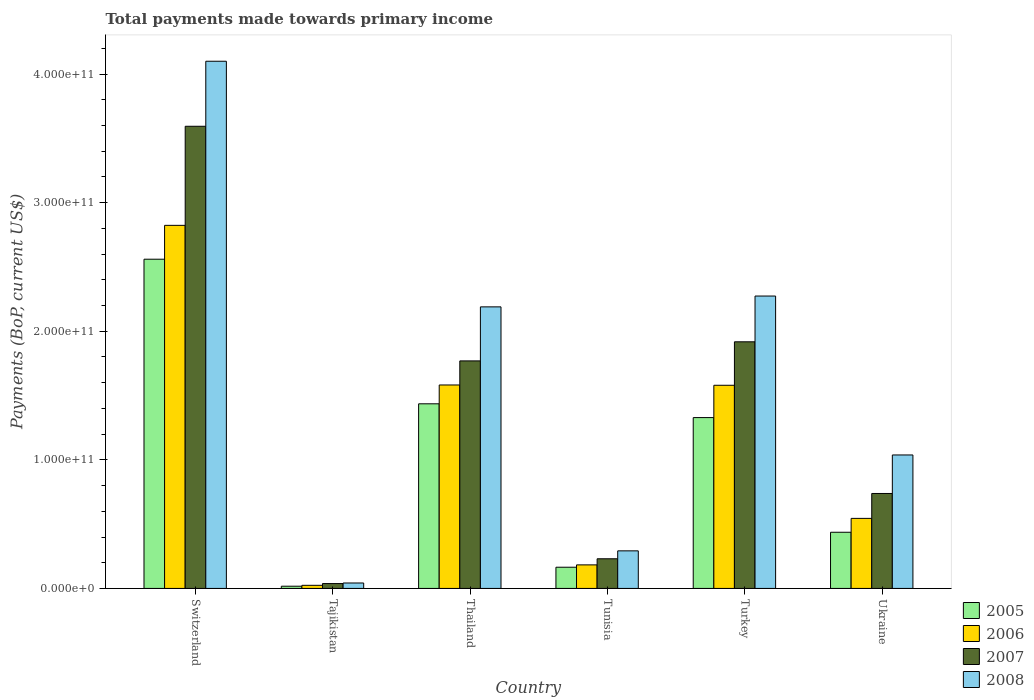How many different coloured bars are there?
Your response must be concise. 4. How many groups of bars are there?
Keep it short and to the point. 6. Are the number of bars on each tick of the X-axis equal?
Keep it short and to the point. Yes. How many bars are there on the 3rd tick from the left?
Give a very brief answer. 4. How many bars are there on the 6th tick from the right?
Offer a very short reply. 4. What is the label of the 4th group of bars from the left?
Your response must be concise. Tunisia. In how many cases, is the number of bars for a given country not equal to the number of legend labels?
Ensure brevity in your answer.  0. What is the total payments made towards primary income in 2005 in Ukraine?
Your answer should be very brief. 4.37e+1. Across all countries, what is the maximum total payments made towards primary income in 2008?
Make the answer very short. 4.10e+11. Across all countries, what is the minimum total payments made towards primary income in 2007?
Keep it short and to the point. 3.78e+09. In which country was the total payments made towards primary income in 2005 maximum?
Ensure brevity in your answer.  Switzerland. In which country was the total payments made towards primary income in 2008 minimum?
Provide a short and direct response. Tajikistan. What is the total total payments made towards primary income in 2005 in the graph?
Ensure brevity in your answer.  5.94e+11. What is the difference between the total payments made towards primary income in 2007 in Tajikistan and that in Turkey?
Your answer should be very brief. -1.88e+11. What is the difference between the total payments made towards primary income in 2006 in Thailand and the total payments made towards primary income in 2007 in Ukraine?
Provide a short and direct response. 8.44e+1. What is the average total payments made towards primary income in 2006 per country?
Your answer should be compact. 1.12e+11. What is the difference between the total payments made towards primary income of/in 2008 and total payments made towards primary income of/in 2005 in Turkey?
Your response must be concise. 9.45e+1. What is the ratio of the total payments made towards primary income in 2006 in Thailand to that in Tunisia?
Provide a succinct answer. 8.64. Is the difference between the total payments made towards primary income in 2008 in Thailand and Ukraine greater than the difference between the total payments made towards primary income in 2005 in Thailand and Ukraine?
Offer a terse response. Yes. What is the difference between the highest and the second highest total payments made towards primary income in 2007?
Offer a terse response. 1.82e+11. What is the difference between the highest and the lowest total payments made towards primary income in 2008?
Give a very brief answer. 4.06e+11. Is the sum of the total payments made towards primary income in 2008 in Tajikistan and Turkey greater than the maximum total payments made towards primary income in 2006 across all countries?
Give a very brief answer. No. Is it the case that in every country, the sum of the total payments made towards primary income in 2005 and total payments made towards primary income in 2007 is greater than the sum of total payments made towards primary income in 2008 and total payments made towards primary income in 2006?
Keep it short and to the point. No. Is it the case that in every country, the sum of the total payments made towards primary income in 2006 and total payments made towards primary income in 2005 is greater than the total payments made towards primary income in 2007?
Your response must be concise. Yes. How many bars are there?
Make the answer very short. 24. How many countries are there in the graph?
Your response must be concise. 6. What is the difference between two consecutive major ticks on the Y-axis?
Keep it short and to the point. 1.00e+11. Are the values on the major ticks of Y-axis written in scientific E-notation?
Give a very brief answer. Yes. What is the title of the graph?
Your answer should be very brief. Total payments made towards primary income. Does "1979" appear as one of the legend labels in the graph?
Offer a terse response. No. What is the label or title of the Y-axis?
Make the answer very short. Payments (BoP, current US$). What is the Payments (BoP, current US$) of 2005 in Switzerland?
Give a very brief answer. 2.56e+11. What is the Payments (BoP, current US$) of 2006 in Switzerland?
Keep it short and to the point. 2.82e+11. What is the Payments (BoP, current US$) in 2007 in Switzerland?
Provide a succinct answer. 3.59e+11. What is the Payments (BoP, current US$) of 2008 in Switzerland?
Give a very brief answer. 4.10e+11. What is the Payments (BoP, current US$) in 2005 in Tajikistan?
Make the answer very short. 1.73e+09. What is the Payments (BoP, current US$) in 2006 in Tajikistan?
Make the answer very short. 2.43e+09. What is the Payments (BoP, current US$) in 2007 in Tajikistan?
Offer a terse response. 3.78e+09. What is the Payments (BoP, current US$) of 2008 in Tajikistan?
Your response must be concise. 4.23e+09. What is the Payments (BoP, current US$) in 2005 in Thailand?
Provide a succinct answer. 1.44e+11. What is the Payments (BoP, current US$) in 2006 in Thailand?
Offer a very short reply. 1.58e+11. What is the Payments (BoP, current US$) of 2007 in Thailand?
Provide a succinct answer. 1.77e+11. What is the Payments (BoP, current US$) of 2008 in Thailand?
Provide a succinct answer. 2.19e+11. What is the Payments (BoP, current US$) in 2005 in Tunisia?
Provide a short and direct response. 1.65e+1. What is the Payments (BoP, current US$) of 2006 in Tunisia?
Your answer should be very brief. 1.83e+1. What is the Payments (BoP, current US$) in 2007 in Tunisia?
Provide a short and direct response. 2.31e+1. What is the Payments (BoP, current US$) of 2008 in Tunisia?
Provide a succinct answer. 2.92e+1. What is the Payments (BoP, current US$) in 2005 in Turkey?
Provide a short and direct response. 1.33e+11. What is the Payments (BoP, current US$) of 2006 in Turkey?
Ensure brevity in your answer.  1.58e+11. What is the Payments (BoP, current US$) in 2007 in Turkey?
Provide a short and direct response. 1.92e+11. What is the Payments (BoP, current US$) in 2008 in Turkey?
Offer a terse response. 2.27e+11. What is the Payments (BoP, current US$) in 2005 in Ukraine?
Offer a terse response. 4.37e+1. What is the Payments (BoP, current US$) in 2006 in Ukraine?
Your answer should be compact. 5.45e+1. What is the Payments (BoP, current US$) of 2007 in Ukraine?
Keep it short and to the point. 7.39e+1. What is the Payments (BoP, current US$) of 2008 in Ukraine?
Keep it short and to the point. 1.04e+11. Across all countries, what is the maximum Payments (BoP, current US$) of 2005?
Provide a succinct answer. 2.56e+11. Across all countries, what is the maximum Payments (BoP, current US$) in 2006?
Ensure brevity in your answer.  2.82e+11. Across all countries, what is the maximum Payments (BoP, current US$) in 2007?
Provide a succinct answer. 3.59e+11. Across all countries, what is the maximum Payments (BoP, current US$) in 2008?
Provide a succinct answer. 4.10e+11. Across all countries, what is the minimum Payments (BoP, current US$) in 2005?
Your answer should be very brief. 1.73e+09. Across all countries, what is the minimum Payments (BoP, current US$) of 2006?
Provide a short and direct response. 2.43e+09. Across all countries, what is the minimum Payments (BoP, current US$) of 2007?
Keep it short and to the point. 3.78e+09. Across all countries, what is the minimum Payments (BoP, current US$) in 2008?
Offer a very short reply. 4.23e+09. What is the total Payments (BoP, current US$) in 2005 in the graph?
Your response must be concise. 5.94e+11. What is the total Payments (BoP, current US$) in 2006 in the graph?
Give a very brief answer. 6.74e+11. What is the total Payments (BoP, current US$) in 2007 in the graph?
Keep it short and to the point. 8.29e+11. What is the total Payments (BoP, current US$) of 2008 in the graph?
Keep it short and to the point. 9.94e+11. What is the difference between the Payments (BoP, current US$) of 2005 in Switzerland and that in Tajikistan?
Make the answer very short. 2.54e+11. What is the difference between the Payments (BoP, current US$) of 2006 in Switzerland and that in Tajikistan?
Your answer should be compact. 2.80e+11. What is the difference between the Payments (BoP, current US$) in 2007 in Switzerland and that in Tajikistan?
Make the answer very short. 3.56e+11. What is the difference between the Payments (BoP, current US$) of 2008 in Switzerland and that in Tajikistan?
Your answer should be compact. 4.06e+11. What is the difference between the Payments (BoP, current US$) in 2005 in Switzerland and that in Thailand?
Your response must be concise. 1.12e+11. What is the difference between the Payments (BoP, current US$) of 2006 in Switzerland and that in Thailand?
Your response must be concise. 1.24e+11. What is the difference between the Payments (BoP, current US$) in 2007 in Switzerland and that in Thailand?
Make the answer very short. 1.82e+11. What is the difference between the Payments (BoP, current US$) of 2008 in Switzerland and that in Thailand?
Your answer should be compact. 1.91e+11. What is the difference between the Payments (BoP, current US$) in 2005 in Switzerland and that in Tunisia?
Your answer should be very brief. 2.40e+11. What is the difference between the Payments (BoP, current US$) of 2006 in Switzerland and that in Tunisia?
Provide a succinct answer. 2.64e+11. What is the difference between the Payments (BoP, current US$) of 2007 in Switzerland and that in Tunisia?
Offer a terse response. 3.36e+11. What is the difference between the Payments (BoP, current US$) of 2008 in Switzerland and that in Tunisia?
Your answer should be very brief. 3.81e+11. What is the difference between the Payments (BoP, current US$) of 2005 in Switzerland and that in Turkey?
Ensure brevity in your answer.  1.23e+11. What is the difference between the Payments (BoP, current US$) of 2006 in Switzerland and that in Turkey?
Keep it short and to the point. 1.24e+11. What is the difference between the Payments (BoP, current US$) of 2007 in Switzerland and that in Turkey?
Your answer should be very brief. 1.68e+11. What is the difference between the Payments (BoP, current US$) in 2008 in Switzerland and that in Turkey?
Make the answer very short. 1.83e+11. What is the difference between the Payments (BoP, current US$) in 2005 in Switzerland and that in Ukraine?
Provide a short and direct response. 2.12e+11. What is the difference between the Payments (BoP, current US$) of 2006 in Switzerland and that in Ukraine?
Make the answer very short. 2.28e+11. What is the difference between the Payments (BoP, current US$) of 2007 in Switzerland and that in Ukraine?
Offer a terse response. 2.86e+11. What is the difference between the Payments (BoP, current US$) of 2008 in Switzerland and that in Ukraine?
Offer a very short reply. 3.06e+11. What is the difference between the Payments (BoP, current US$) of 2005 in Tajikistan and that in Thailand?
Ensure brevity in your answer.  -1.42e+11. What is the difference between the Payments (BoP, current US$) of 2006 in Tajikistan and that in Thailand?
Provide a succinct answer. -1.56e+11. What is the difference between the Payments (BoP, current US$) in 2007 in Tajikistan and that in Thailand?
Keep it short and to the point. -1.73e+11. What is the difference between the Payments (BoP, current US$) in 2008 in Tajikistan and that in Thailand?
Ensure brevity in your answer.  -2.15e+11. What is the difference between the Payments (BoP, current US$) in 2005 in Tajikistan and that in Tunisia?
Your answer should be compact. -1.48e+1. What is the difference between the Payments (BoP, current US$) in 2006 in Tajikistan and that in Tunisia?
Your answer should be compact. -1.59e+1. What is the difference between the Payments (BoP, current US$) of 2007 in Tajikistan and that in Tunisia?
Ensure brevity in your answer.  -1.93e+1. What is the difference between the Payments (BoP, current US$) in 2008 in Tajikistan and that in Tunisia?
Ensure brevity in your answer.  -2.50e+1. What is the difference between the Payments (BoP, current US$) of 2005 in Tajikistan and that in Turkey?
Make the answer very short. -1.31e+11. What is the difference between the Payments (BoP, current US$) in 2006 in Tajikistan and that in Turkey?
Your response must be concise. -1.56e+11. What is the difference between the Payments (BoP, current US$) of 2007 in Tajikistan and that in Turkey?
Offer a very short reply. -1.88e+11. What is the difference between the Payments (BoP, current US$) of 2008 in Tajikistan and that in Turkey?
Make the answer very short. -2.23e+11. What is the difference between the Payments (BoP, current US$) of 2005 in Tajikistan and that in Ukraine?
Ensure brevity in your answer.  -4.20e+1. What is the difference between the Payments (BoP, current US$) of 2006 in Tajikistan and that in Ukraine?
Ensure brevity in your answer.  -5.21e+1. What is the difference between the Payments (BoP, current US$) in 2007 in Tajikistan and that in Ukraine?
Provide a short and direct response. -7.01e+1. What is the difference between the Payments (BoP, current US$) of 2008 in Tajikistan and that in Ukraine?
Make the answer very short. -9.96e+1. What is the difference between the Payments (BoP, current US$) in 2005 in Thailand and that in Tunisia?
Your answer should be compact. 1.27e+11. What is the difference between the Payments (BoP, current US$) in 2006 in Thailand and that in Tunisia?
Provide a short and direct response. 1.40e+11. What is the difference between the Payments (BoP, current US$) in 2007 in Thailand and that in Tunisia?
Provide a succinct answer. 1.54e+11. What is the difference between the Payments (BoP, current US$) in 2008 in Thailand and that in Tunisia?
Make the answer very short. 1.90e+11. What is the difference between the Payments (BoP, current US$) of 2005 in Thailand and that in Turkey?
Your answer should be compact. 1.07e+1. What is the difference between the Payments (BoP, current US$) in 2006 in Thailand and that in Turkey?
Offer a very short reply. 2.24e+08. What is the difference between the Payments (BoP, current US$) in 2007 in Thailand and that in Turkey?
Your response must be concise. -1.48e+1. What is the difference between the Payments (BoP, current US$) of 2008 in Thailand and that in Turkey?
Ensure brevity in your answer.  -8.42e+09. What is the difference between the Payments (BoP, current US$) of 2005 in Thailand and that in Ukraine?
Provide a short and direct response. 9.99e+1. What is the difference between the Payments (BoP, current US$) of 2006 in Thailand and that in Ukraine?
Your response must be concise. 1.04e+11. What is the difference between the Payments (BoP, current US$) in 2007 in Thailand and that in Ukraine?
Make the answer very short. 1.03e+11. What is the difference between the Payments (BoP, current US$) in 2008 in Thailand and that in Ukraine?
Keep it short and to the point. 1.15e+11. What is the difference between the Payments (BoP, current US$) of 2005 in Tunisia and that in Turkey?
Keep it short and to the point. -1.16e+11. What is the difference between the Payments (BoP, current US$) in 2006 in Tunisia and that in Turkey?
Make the answer very short. -1.40e+11. What is the difference between the Payments (BoP, current US$) in 2007 in Tunisia and that in Turkey?
Provide a succinct answer. -1.69e+11. What is the difference between the Payments (BoP, current US$) in 2008 in Tunisia and that in Turkey?
Offer a very short reply. -1.98e+11. What is the difference between the Payments (BoP, current US$) of 2005 in Tunisia and that in Ukraine?
Your answer should be compact. -2.72e+1. What is the difference between the Payments (BoP, current US$) of 2006 in Tunisia and that in Ukraine?
Provide a succinct answer. -3.62e+1. What is the difference between the Payments (BoP, current US$) of 2007 in Tunisia and that in Ukraine?
Your answer should be compact. -5.08e+1. What is the difference between the Payments (BoP, current US$) in 2008 in Tunisia and that in Ukraine?
Give a very brief answer. -7.46e+1. What is the difference between the Payments (BoP, current US$) of 2005 in Turkey and that in Ukraine?
Ensure brevity in your answer.  8.92e+1. What is the difference between the Payments (BoP, current US$) in 2006 in Turkey and that in Ukraine?
Keep it short and to the point. 1.04e+11. What is the difference between the Payments (BoP, current US$) in 2007 in Turkey and that in Ukraine?
Provide a short and direct response. 1.18e+11. What is the difference between the Payments (BoP, current US$) in 2008 in Turkey and that in Ukraine?
Offer a very short reply. 1.24e+11. What is the difference between the Payments (BoP, current US$) of 2005 in Switzerland and the Payments (BoP, current US$) of 2006 in Tajikistan?
Provide a short and direct response. 2.54e+11. What is the difference between the Payments (BoP, current US$) of 2005 in Switzerland and the Payments (BoP, current US$) of 2007 in Tajikistan?
Your answer should be very brief. 2.52e+11. What is the difference between the Payments (BoP, current US$) in 2005 in Switzerland and the Payments (BoP, current US$) in 2008 in Tajikistan?
Offer a very short reply. 2.52e+11. What is the difference between the Payments (BoP, current US$) in 2006 in Switzerland and the Payments (BoP, current US$) in 2007 in Tajikistan?
Provide a succinct answer. 2.79e+11. What is the difference between the Payments (BoP, current US$) of 2006 in Switzerland and the Payments (BoP, current US$) of 2008 in Tajikistan?
Your answer should be compact. 2.78e+11. What is the difference between the Payments (BoP, current US$) of 2007 in Switzerland and the Payments (BoP, current US$) of 2008 in Tajikistan?
Your answer should be compact. 3.55e+11. What is the difference between the Payments (BoP, current US$) in 2005 in Switzerland and the Payments (BoP, current US$) in 2006 in Thailand?
Provide a succinct answer. 9.78e+1. What is the difference between the Payments (BoP, current US$) in 2005 in Switzerland and the Payments (BoP, current US$) in 2007 in Thailand?
Your response must be concise. 7.91e+1. What is the difference between the Payments (BoP, current US$) of 2005 in Switzerland and the Payments (BoP, current US$) of 2008 in Thailand?
Provide a short and direct response. 3.71e+1. What is the difference between the Payments (BoP, current US$) in 2006 in Switzerland and the Payments (BoP, current US$) in 2007 in Thailand?
Offer a very short reply. 1.05e+11. What is the difference between the Payments (BoP, current US$) of 2006 in Switzerland and the Payments (BoP, current US$) of 2008 in Thailand?
Your response must be concise. 6.34e+1. What is the difference between the Payments (BoP, current US$) of 2007 in Switzerland and the Payments (BoP, current US$) of 2008 in Thailand?
Offer a very short reply. 1.40e+11. What is the difference between the Payments (BoP, current US$) of 2005 in Switzerland and the Payments (BoP, current US$) of 2006 in Tunisia?
Make the answer very short. 2.38e+11. What is the difference between the Payments (BoP, current US$) of 2005 in Switzerland and the Payments (BoP, current US$) of 2007 in Tunisia?
Ensure brevity in your answer.  2.33e+11. What is the difference between the Payments (BoP, current US$) in 2005 in Switzerland and the Payments (BoP, current US$) in 2008 in Tunisia?
Keep it short and to the point. 2.27e+11. What is the difference between the Payments (BoP, current US$) in 2006 in Switzerland and the Payments (BoP, current US$) in 2007 in Tunisia?
Give a very brief answer. 2.59e+11. What is the difference between the Payments (BoP, current US$) in 2006 in Switzerland and the Payments (BoP, current US$) in 2008 in Tunisia?
Ensure brevity in your answer.  2.53e+11. What is the difference between the Payments (BoP, current US$) of 2007 in Switzerland and the Payments (BoP, current US$) of 2008 in Tunisia?
Offer a very short reply. 3.30e+11. What is the difference between the Payments (BoP, current US$) of 2005 in Switzerland and the Payments (BoP, current US$) of 2006 in Turkey?
Give a very brief answer. 9.80e+1. What is the difference between the Payments (BoP, current US$) of 2005 in Switzerland and the Payments (BoP, current US$) of 2007 in Turkey?
Keep it short and to the point. 6.42e+1. What is the difference between the Payments (BoP, current US$) of 2005 in Switzerland and the Payments (BoP, current US$) of 2008 in Turkey?
Give a very brief answer. 2.86e+1. What is the difference between the Payments (BoP, current US$) of 2006 in Switzerland and the Payments (BoP, current US$) of 2007 in Turkey?
Ensure brevity in your answer.  9.06e+1. What is the difference between the Payments (BoP, current US$) in 2006 in Switzerland and the Payments (BoP, current US$) in 2008 in Turkey?
Keep it short and to the point. 5.50e+1. What is the difference between the Payments (BoP, current US$) of 2007 in Switzerland and the Payments (BoP, current US$) of 2008 in Turkey?
Give a very brief answer. 1.32e+11. What is the difference between the Payments (BoP, current US$) in 2005 in Switzerland and the Payments (BoP, current US$) in 2006 in Ukraine?
Your answer should be compact. 2.02e+11. What is the difference between the Payments (BoP, current US$) in 2005 in Switzerland and the Payments (BoP, current US$) in 2007 in Ukraine?
Your answer should be compact. 1.82e+11. What is the difference between the Payments (BoP, current US$) in 2005 in Switzerland and the Payments (BoP, current US$) in 2008 in Ukraine?
Your answer should be very brief. 1.52e+11. What is the difference between the Payments (BoP, current US$) of 2006 in Switzerland and the Payments (BoP, current US$) of 2007 in Ukraine?
Make the answer very short. 2.09e+11. What is the difference between the Payments (BoP, current US$) of 2006 in Switzerland and the Payments (BoP, current US$) of 2008 in Ukraine?
Offer a terse response. 1.79e+11. What is the difference between the Payments (BoP, current US$) of 2007 in Switzerland and the Payments (BoP, current US$) of 2008 in Ukraine?
Your answer should be compact. 2.56e+11. What is the difference between the Payments (BoP, current US$) of 2005 in Tajikistan and the Payments (BoP, current US$) of 2006 in Thailand?
Your response must be concise. -1.57e+11. What is the difference between the Payments (BoP, current US$) in 2005 in Tajikistan and the Payments (BoP, current US$) in 2007 in Thailand?
Offer a very short reply. -1.75e+11. What is the difference between the Payments (BoP, current US$) of 2005 in Tajikistan and the Payments (BoP, current US$) of 2008 in Thailand?
Your response must be concise. -2.17e+11. What is the difference between the Payments (BoP, current US$) in 2006 in Tajikistan and the Payments (BoP, current US$) in 2007 in Thailand?
Provide a succinct answer. -1.75e+11. What is the difference between the Payments (BoP, current US$) of 2006 in Tajikistan and the Payments (BoP, current US$) of 2008 in Thailand?
Your answer should be compact. -2.17e+11. What is the difference between the Payments (BoP, current US$) in 2007 in Tajikistan and the Payments (BoP, current US$) in 2008 in Thailand?
Your answer should be very brief. -2.15e+11. What is the difference between the Payments (BoP, current US$) of 2005 in Tajikistan and the Payments (BoP, current US$) of 2006 in Tunisia?
Keep it short and to the point. -1.66e+1. What is the difference between the Payments (BoP, current US$) in 2005 in Tajikistan and the Payments (BoP, current US$) in 2007 in Tunisia?
Your response must be concise. -2.13e+1. What is the difference between the Payments (BoP, current US$) of 2005 in Tajikistan and the Payments (BoP, current US$) of 2008 in Tunisia?
Offer a terse response. -2.75e+1. What is the difference between the Payments (BoP, current US$) of 2006 in Tajikistan and the Payments (BoP, current US$) of 2007 in Tunisia?
Offer a very short reply. -2.06e+1. What is the difference between the Payments (BoP, current US$) in 2006 in Tajikistan and the Payments (BoP, current US$) in 2008 in Tunisia?
Your response must be concise. -2.68e+1. What is the difference between the Payments (BoP, current US$) of 2007 in Tajikistan and the Payments (BoP, current US$) of 2008 in Tunisia?
Ensure brevity in your answer.  -2.55e+1. What is the difference between the Payments (BoP, current US$) in 2005 in Tajikistan and the Payments (BoP, current US$) in 2006 in Turkey?
Give a very brief answer. -1.56e+11. What is the difference between the Payments (BoP, current US$) of 2005 in Tajikistan and the Payments (BoP, current US$) of 2007 in Turkey?
Your response must be concise. -1.90e+11. What is the difference between the Payments (BoP, current US$) of 2005 in Tajikistan and the Payments (BoP, current US$) of 2008 in Turkey?
Make the answer very short. -2.26e+11. What is the difference between the Payments (BoP, current US$) of 2006 in Tajikistan and the Payments (BoP, current US$) of 2007 in Turkey?
Your answer should be compact. -1.89e+11. What is the difference between the Payments (BoP, current US$) in 2006 in Tajikistan and the Payments (BoP, current US$) in 2008 in Turkey?
Your answer should be compact. -2.25e+11. What is the difference between the Payments (BoP, current US$) in 2007 in Tajikistan and the Payments (BoP, current US$) in 2008 in Turkey?
Provide a succinct answer. -2.24e+11. What is the difference between the Payments (BoP, current US$) of 2005 in Tajikistan and the Payments (BoP, current US$) of 2006 in Ukraine?
Provide a short and direct response. -5.27e+1. What is the difference between the Payments (BoP, current US$) of 2005 in Tajikistan and the Payments (BoP, current US$) of 2007 in Ukraine?
Keep it short and to the point. -7.21e+1. What is the difference between the Payments (BoP, current US$) in 2005 in Tajikistan and the Payments (BoP, current US$) in 2008 in Ukraine?
Give a very brief answer. -1.02e+11. What is the difference between the Payments (BoP, current US$) in 2006 in Tajikistan and the Payments (BoP, current US$) in 2007 in Ukraine?
Your answer should be compact. -7.14e+1. What is the difference between the Payments (BoP, current US$) in 2006 in Tajikistan and the Payments (BoP, current US$) in 2008 in Ukraine?
Provide a short and direct response. -1.01e+11. What is the difference between the Payments (BoP, current US$) in 2007 in Tajikistan and the Payments (BoP, current US$) in 2008 in Ukraine?
Keep it short and to the point. -1.00e+11. What is the difference between the Payments (BoP, current US$) of 2005 in Thailand and the Payments (BoP, current US$) of 2006 in Tunisia?
Provide a succinct answer. 1.25e+11. What is the difference between the Payments (BoP, current US$) of 2005 in Thailand and the Payments (BoP, current US$) of 2007 in Tunisia?
Provide a succinct answer. 1.21e+11. What is the difference between the Payments (BoP, current US$) of 2005 in Thailand and the Payments (BoP, current US$) of 2008 in Tunisia?
Offer a very short reply. 1.14e+11. What is the difference between the Payments (BoP, current US$) in 2006 in Thailand and the Payments (BoP, current US$) in 2007 in Tunisia?
Offer a terse response. 1.35e+11. What is the difference between the Payments (BoP, current US$) of 2006 in Thailand and the Payments (BoP, current US$) of 2008 in Tunisia?
Provide a short and direct response. 1.29e+11. What is the difference between the Payments (BoP, current US$) in 2007 in Thailand and the Payments (BoP, current US$) in 2008 in Tunisia?
Keep it short and to the point. 1.48e+11. What is the difference between the Payments (BoP, current US$) of 2005 in Thailand and the Payments (BoP, current US$) of 2006 in Turkey?
Your answer should be compact. -1.44e+1. What is the difference between the Payments (BoP, current US$) of 2005 in Thailand and the Payments (BoP, current US$) of 2007 in Turkey?
Offer a very short reply. -4.82e+1. What is the difference between the Payments (BoP, current US$) of 2005 in Thailand and the Payments (BoP, current US$) of 2008 in Turkey?
Your answer should be very brief. -8.38e+1. What is the difference between the Payments (BoP, current US$) in 2006 in Thailand and the Payments (BoP, current US$) in 2007 in Turkey?
Offer a terse response. -3.36e+1. What is the difference between the Payments (BoP, current US$) in 2006 in Thailand and the Payments (BoP, current US$) in 2008 in Turkey?
Your response must be concise. -6.92e+1. What is the difference between the Payments (BoP, current US$) of 2007 in Thailand and the Payments (BoP, current US$) of 2008 in Turkey?
Your answer should be very brief. -5.04e+1. What is the difference between the Payments (BoP, current US$) in 2005 in Thailand and the Payments (BoP, current US$) in 2006 in Ukraine?
Offer a terse response. 8.91e+1. What is the difference between the Payments (BoP, current US$) in 2005 in Thailand and the Payments (BoP, current US$) in 2007 in Ukraine?
Give a very brief answer. 6.97e+1. What is the difference between the Payments (BoP, current US$) of 2005 in Thailand and the Payments (BoP, current US$) of 2008 in Ukraine?
Your answer should be compact. 3.98e+1. What is the difference between the Payments (BoP, current US$) of 2006 in Thailand and the Payments (BoP, current US$) of 2007 in Ukraine?
Ensure brevity in your answer.  8.44e+1. What is the difference between the Payments (BoP, current US$) in 2006 in Thailand and the Payments (BoP, current US$) in 2008 in Ukraine?
Provide a succinct answer. 5.44e+1. What is the difference between the Payments (BoP, current US$) in 2007 in Thailand and the Payments (BoP, current US$) in 2008 in Ukraine?
Your response must be concise. 7.32e+1. What is the difference between the Payments (BoP, current US$) in 2005 in Tunisia and the Payments (BoP, current US$) in 2006 in Turkey?
Make the answer very short. -1.42e+11. What is the difference between the Payments (BoP, current US$) of 2005 in Tunisia and the Payments (BoP, current US$) of 2007 in Turkey?
Keep it short and to the point. -1.75e+11. What is the difference between the Payments (BoP, current US$) in 2005 in Tunisia and the Payments (BoP, current US$) in 2008 in Turkey?
Give a very brief answer. -2.11e+11. What is the difference between the Payments (BoP, current US$) of 2006 in Tunisia and the Payments (BoP, current US$) of 2007 in Turkey?
Offer a very short reply. -1.73e+11. What is the difference between the Payments (BoP, current US$) of 2006 in Tunisia and the Payments (BoP, current US$) of 2008 in Turkey?
Provide a short and direct response. -2.09e+11. What is the difference between the Payments (BoP, current US$) in 2007 in Tunisia and the Payments (BoP, current US$) in 2008 in Turkey?
Make the answer very short. -2.04e+11. What is the difference between the Payments (BoP, current US$) of 2005 in Tunisia and the Payments (BoP, current US$) of 2006 in Ukraine?
Give a very brief answer. -3.80e+1. What is the difference between the Payments (BoP, current US$) of 2005 in Tunisia and the Payments (BoP, current US$) of 2007 in Ukraine?
Give a very brief answer. -5.74e+1. What is the difference between the Payments (BoP, current US$) in 2005 in Tunisia and the Payments (BoP, current US$) in 2008 in Ukraine?
Provide a short and direct response. -8.73e+1. What is the difference between the Payments (BoP, current US$) of 2006 in Tunisia and the Payments (BoP, current US$) of 2007 in Ukraine?
Your answer should be compact. -5.55e+1. What is the difference between the Payments (BoP, current US$) of 2006 in Tunisia and the Payments (BoP, current US$) of 2008 in Ukraine?
Keep it short and to the point. -8.55e+1. What is the difference between the Payments (BoP, current US$) in 2007 in Tunisia and the Payments (BoP, current US$) in 2008 in Ukraine?
Offer a terse response. -8.07e+1. What is the difference between the Payments (BoP, current US$) of 2005 in Turkey and the Payments (BoP, current US$) of 2006 in Ukraine?
Provide a short and direct response. 7.84e+1. What is the difference between the Payments (BoP, current US$) in 2005 in Turkey and the Payments (BoP, current US$) in 2007 in Ukraine?
Ensure brevity in your answer.  5.90e+1. What is the difference between the Payments (BoP, current US$) in 2005 in Turkey and the Payments (BoP, current US$) in 2008 in Ukraine?
Your response must be concise. 2.91e+1. What is the difference between the Payments (BoP, current US$) of 2006 in Turkey and the Payments (BoP, current US$) of 2007 in Ukraine?
Your answer should be compact. 8.42e+1. What is the difference between the Payments (BoP, current US$) of 2006 in Turkey and the Payments (BoP, current US$) of 2008 in Ukraine?
Ensure brevity in your answer.  5.42e+1. What is the difference between the Payments (BoP, current US$) of 2007 in Turkey and the Payments (BoP, current US$) of 2008 in Ukraine?
Offer a terse response. 8.80e+1. What is the average Payments (BoP, current US$) of 2005 per country?
Ensure brevity in your answer.  9.91e+1. What is the average Payments (BoP, current US$) of 2006 per country?
Your answer should be compact. 1.12e+11. What is the average Payments (BoP, current US$) in 2007 per country?
Ensure brevity in your answer.  1.38e+11. What is the average Payments (BoP, current US$) in 2008 per country?
Keep it short and to the point. 1.66e+11. What is the difference between the Payments (BoP, current US$) in 2005 and Payments (BoP, current US$) in 2006 in Switzerland?
Ensure brevity in your answer.  -2.63e+1. What is the difference between the Payments (BoP, current US$) of 2005 and Payments (BoP, current US$) of 2007 in Switzerland?
Offer a terse response. -1.03e+11. What is the difference between the Payments (BoP, current US$) of 2005 and Payments (BoP, current US$) of 2008 in Switzerland?
Ensure brevity in your answer.  -1.54e+11. What is the difference between the Payments (BoP, current US$) in 2006 and Payments (BoP, current US$) in 2007 in Switzerland?
Offer a very short reply. -7.71e+1. What is the difference between the Payments (BoP, current US$) of 2006 and Payments (BoP, current US$) of 2008 in Switzerland?
Offer a terse response. -1.28e+11. What is the difference between the Payments (BoP, current US$) of 2007 and Payments (BoP, current US$) of 2008 in Switzerland?
Ensure brevity in your answer.  -5.06e+1. What is the difference between the Payments (BoP, current US$) in 2005 and Payments (BoP, current US$) in 2006 in Tajikistan?
Your response must be concise. -6.93e+08. What is the difference between the Payments (BoP, current US$) of 2005 and Payments (BoP, current US$) of 2007 in Tajikistan?
Your answer should be very brief. -2.05e+09. What is the difference between the Payments (BoP, current US$) in 2005 and Payments (BoP, current US$) in 2008 in Tajikistan?
Provide a short and direct response. -2.49e+09. What is the difference between the Payments (BoP, current US$) in 2006 and Payments (BoP, current US$) in 2007 in Tajikistan?
Give a very brief answer. -1.35e+09. What is the difference between the Payments (BoP, current US$) in 2006 and Payments (BoP, current US$) in 2008 in Tajikistan?
Provide a succinct answer. -1.80e+09. What is the difference between the Payments (BoP, current US$) of 2007 and Payments (BoP, current US$) of 2008 in Tajikistan?
Your answer should be compact. -4.47e+08. What is the difference between the Payments (BoP, current US$) in 2005 and Payments (BoP, current US$) in 2006 in Thailand?
Your answer should be compact. -1.46e+1. What is the difference between the Payments (BoP, current US$) in 2005 and Payments (BoP, current US$) in 2007 in Thailand?
Keep it short and to the point. -3.34e+1. What is the difference between the Payments (BoP, current US$) in 2005 and Payments (BoP, current US$) in 2008 in Thailand?
Make the answer very short. -7.54e+1. What is the difference between the Payments (BoP, current US$) in 2006 and Payments (BoP, current US$) in 2007 in Thailand?
Your answer should be compact. -1.87e+1. What is the difference between the Payments (BoP, current US$) of 2006 and Payments (BoP, current US$) of 2008 in Thailand?
Keep it short and to the point. -6.08e+1. What is the difference between the Payments (BoP, current US$) of 2007 and Payments (BoP, current US$) of 2008 in Thailand?
Make the answer very short. -4.20e+1. What is the difference between the Payments (BoP, current US$) in 2005 and Payments (BoP, current US$) in 2006 in Tunisia?
Your answer should be compact. -1.82e+09. What is the difference between the Payments (BoP, current US$) in 2005 and Payments (BoP, current US$) in 2007 in Tunisia?
Your answer should be very brief. -6.57e+09. What is the difference between the Payments (BoP, current US$) of 2005 and Payments (BoP, current US$) of 2008 in Tunisia?
Ensure brevity in your answer.  -1.27e+1. What is the difference between the Payments (BoP, current US$) of 2006 and Payments (BoP, current US$) of 2007 in Tunisia?
Ensure brevity in your answer.  -4.74e+09. What is the difference between the Payments (BoP, current US$) in 2006 and Payments (BoP, current US$) in 2008 in Tunisia?
Offer a terse response. -1.09e+1. What is the difference between the Payments (BoP, current US$) of 2007 and Payments (BoP, current US$) of 2008 in Tunisia?
Offer a terse response. -6.17e+09. What is the difference between the Payments (BoP, current US$) of 2005 and Payments (BoP, current US$) of 2006 in Turkey?
Your response must be concise. -2.51e+1. What is the difference between the Payments (BoP, current US$) in 2005 and Payments (BoP, current US$) in 2007 in Turkey?
Your response must be concise. -5.89e+1. What is the difference between the Payments (BoP, current US$) in 2005 and Payments (BoP, current US$) in 2008 in Turkey?
Your answer should be very brief. -9.45e+1. What is the difference between the Payments (BoP, current US$) in 2006 and Payments (BoP, current US$) in 2007 in Turkey?
Ensure brevity in your answer.  -3.38e+1. What is the difference between the Payments (BoP, current US$) of 2006 and Payments (BoP, current US$) of 2008 in Turkey?
Make the answer very short. -6.94e+1. What is the difference between the Payments (BoP, current US$) in 2007 and Payments (BoP, current US$) in 2008 in Turkey?
Provide a succinct answer. -3.56e+1. What is the difference between the Payments (BoP, current US$) of 2005 and Payments (BoP, current US$) of 2006 in Ukraine?
Your response must be concise. -1.08e+1. What is the difference between the Payments (BoP, current US$) in 2005 and Payments (BoP, current US$) in 2007 in Ukraine?
Your answer should be compact. -3.02e+1. What is the difference between the Payments (BoP, current US$) of 2005 and Payments (BoP, current US$) of 2008 in Ukraine?
Offer a terse response. -6.01e+1. What is the difference between the Payments (BoP, current US$) of 2006 and Payments (BoP, current US$) of 2007 in Ukraine?
Ensure brevity in your answer.  -1.94e+1. What is the difference between the Payments (BoP, current US$) in 2006 and Payments (BoP, current US$) in 2008 in Ukraine?
Keep it short and to the point. -4.93e+1. What is the difference between the Payments (BoP, current US$) in 2007 and Payments (BoP, current US$) in 2008 in Ukraine?
Your answer should be very brief. -2.99e+1. What is the ratio of the Payments (BoP, current US$) of 2005 in Switzerland to that in Tajikistan?
Keep it short and to the point. 147.77. What is the ratio of the Payments (BoP, current US$) in 2006 in Switzerland to that in Tajikistan?
Make the answer very short. 116.43. What is the ratio of the Payments (BoP, current US$) of 2007 in Switzerland to that in Tajikistan?
Your response must be concise. 95.09. What is the ratio of the Payments (BoP, current US$) in 2008 in Switzerland to that in Tajikistan?
Your response must be concise. 97. What is the ratio of the Payments (BoP, current US$) in 2005 in Switzerland to that in Thailand?
Provide a short and direct response. 1.78. What is the ratio of the Payments (BoP, current US$) of 2006 in Switzerland to that in Thailand?
Your answer should be compact. 1.78. What is the ratio of the Payments (BoP, current US$) of 2007 in Switzerland to that in Thailand?
Make the answer very short. 2.03. What is the ratio of the Payments (BoP, current US$) of 2008 in Switzerland to that in Thailand?
Provide a succinct answer. 1.87. What is the ratio of the Payments (BoP, current US$) in 2005 in Switzerland to that in Tunisia?
Give a very brief answer. 15.52. What is the ratio of the Payments (BoP, current US$) of 2006 in Switzerland to that in Tunisia?
Provide a short and direct response. 15.41. What is the ratio of the Payments (BoP, current US$) in 2007 in Switzerland to that in Tunisia?
Make the answer very short. 15.59. What is the ratio of the Payments (BoP, current US$) in 2008 in Switzerland to that in Tunisia?
Your answer should be compact. 14.03. What is the ratio of the Payments (BoP, current US$) in 2005 in Switzerland to that in Turkey?
Provide a short and direct response. 1.93. What is the ratio of the Payments (BoP, current US$) in 2006 in Switzerland to that in Turkey?
Ensure brevity in your answer.  1.79. What is the ratio of the Payments (BoP, current US$) of 2007 in Switzerland to that in Turkey?
Provide a short and direct response. 1.87. What is the ratio of the Payments (BoP, current US$) in 2008 in Switzerland to that in Turkey?
Ensure brevity in your answer.  1.8. What is the ratio of the Payments (BoP, current US$) in 2005 in Switzerland to that in Ukraine?
Your answer should be very brief. 5.86. What is the ratio of the Payments (BoP, current US$) in 2006 in Switzerland to that in Ukraine?
Your response must be concise. 5.18. What is the ratio of the Payments (BoP, current US$) in 2007 in Switzerland to that in Ukraine?
Your response must be concise. 4.87. What is the ratio of the Payments (BoP, current US$) of 2008 in Switzerland to that in Ukraine?
Your response must be concise. 3.95. What is the ratio of the Payments (BoP, current US$) in 2005 in Tajikistan to that in Thailand?
Provide a short and direct response. 0.01. What is the ratio of the Payments (BoP, current US$) in 2006 in Tajikistan to that in Thailand?
Give a very brief answer. 0.02. What is the ratio of the Payments (BoP, current US$) in 2007 in Tajikistan to that in Thailand?
Offer a very short reply. 0.02. What is the ratio of the Payments (BoP, current US$) of 2008 in Tajikistan to that in Thailand?
Ensure brevity in your answer.  0.02. What is the ratio of the Payments (BoP, current US$) in 2005 in Tajikistan to that in Tunisia?
Ensure brevity in your answer.  0.1. What is the ratio of the Payments (BoP, current US$) in 2006 in Tajikistan to that in Tunisia?
Offer a very short reply. 0.13. What is the ratio of the Payments (BoP, current US$) of 2007 in Tajikistan to that in Tunisia?
Offer a terse response. 0.16. What is the ratio of the Payments (BoP, current US$) of 2008 in Tajikistan to that in Tunisia?
Provide a succinct answer. 0.14. What is the ratio of the Payments (BoP, current US$) of 2005 in Tajikistan to that in Turkey?
Your answer should be very brief. 0.01. What is the ratio of the Payments (BoP, current US$) of 2006 in Tajikistan to that in Turkey?
Your answer should be compact. 0.02. What is the ratio of the Payments (BoP, current US$) in 2007 in Tajikistan to that in Turkey?
Keep it short and to the point. 0.02. What is the ratio of the Payments (BoP, current US$) of 2008 in Tajikistan to that in Turkey?
Provide a succinct answer. 0.02. What is the ratio of the Payments (BoP, current US$) of 2005 in Tajikistan to that in Ukraine?
Offer a very short reply. 0.04. What is the ratio of the Payments (BoP, current US$) of 2006 in Tajikistan to that in Ukraine?
Your answer should be very brief. 0.04. What is the ratio of the Payments (BoP, current US$) in 2007 in Tajikistan to that in Ukraine?
Your answer should be compact. 0.05. What is the ratio of the Payments (BoP, current US$) in 2008 in Tajikistan to that in Ukraine?
Make the answer very short. 0.04. What is the ratio of the Payments (BoP, current US$) of 2005 in Thailand to that in Tunisia?
Provide a succinct answer. 8.7. What is the ratio of the Payments (BoP, current US$) in 2006 in Thailand to that in Tunisia?
Ensure brevity in your answer.  8.64. What is the ratio of the Payments (BoP, current US$) of 2007 in Thailand to that in Tunisia?
Provide a succinct answer. 7.67. What is the ratio of the Payments (BoP, current US$) in 2008 in Thailand to that in Tunisia?
Give a very brief answer. 7.49. What is the ratio of the Payments (BoP, current US$) in 2005 in Thailand to that in Turkey?
Provide a short and direct response. 1.08. What is the ratio of the Payments (BoP, current US$) in 2007 in Thailand to that in Turkey?
Your answer should be compact. 0.92. What is the ratio of the Payments (BoP, current US$) of 2008 in Thailand to that in Turkey?
Keep it short and to the point. 0.96. What is the ratio of the Payments (BoP, current US$) of 2005 in Thailand to that in Ukraine?
Your response must be concise. 3.29. What is the ratio of the Payments (BoP, current US$) in 2006 in Thailand to that in Ukraine?
Give a very brief answer. 2.9. What is the ratio of the Payments (BoP, current US$) in 2007 in Thailand to that in Ukraine?
Ensure brevity in your answer.  2.4. What is the ratio of the Payments (BoP, current US$) in 2008 in Thailand to that in Ukraine?
Keep it short and to the point. 2.11. What is the ratio of the Payments (BoP, current US$) in 2005 in Tunisia to that in Turkey?
Keep it short and to the point. 0.12. What is the ratio of the Payments (BoP, current US$) of 2006 in Tunisia to that in Turkey?
Make the answer very short. 0.12. What is the ratio of the Payments (BoP, current US$) of 2007 in Tunisia to that in Turkey?
Offer a very short reply. 0.12. What is the ratio of the Payments (BoP, current US$) in 2008 in Tunisia to that in Turkey?
Offer a terse response. 0.13. What is the ratio of the Payments (BoP, current US$) in 2005 in Tunisia to that in Ukraine?
Offer a very short reply. 0.38. What is the ratio of the Payments (BoP, current US$) of 2006 in Tunisia to that in Ukraine?
Your answer should be compact. 0.34. What is the ratio of the Payments (BoP, current US$) of 2007 in Tunisia to that in Ukraine?
Keep it short and to the point. 0.31. What is the ratio of the Payments (BoP, current US$) in 2008 in Tunisia to that in Ukraine?
Provide a short and direct response. 0.28. What is the ratio of the Payments (BoP, current US$) of 2005 in Turkey to that in Ukraine?
Give a very brief answer. 3.04. What is the ratio of the Payments (BoP, current US$) of 2006 in Turkey to that in Ukraine?
Offer a very short reply. 2.9. What is the ratio of the Payments (BoP, current US$) in 2007 in Turkey to that in Ukraine?
Keep it short and to the point. 2.6. What is the ratio of the Payments (BoP, current US$) of 2008 in Turkey to that in Ukraine?
Make the answer very short. 2.19. What is the difference between the highest and the second highest Payments (BoP, current US$) of 2005?
Keep it short and to the point. 1.12e+11. What is the difference between the highest and the second highest Payments (BoP, current US$) in 2006?
Your answer should be very brief. 1.24e+11. What is the difference between the highest and the second highest Payments (BoP, current US$) of 2007?
Offer a terse response. 1.68e+11. What is the difference between the highest and the second highest Payments (BoP, current US$) in 2008?
Offer a terse response. 1.83e+11. What is the difference between the highest and the lowest Payments (BoP, current US$) of 2005?
Your response must be concise. 2.54e+11. What is the difference between the highest and the lowest Payments (BoP, current US$) of 2006?
Your answer should be very brief. 2.80e+11. What is the difference between the highest and the lowest Payments (BoP, current US$) in 2007?
Make the answer very short. 3.56e+11. What is the difference between the highest and the lowest Payments (BoP, current US$) of 2008?
Ensure brevity in your answer.  4.06e+11. 